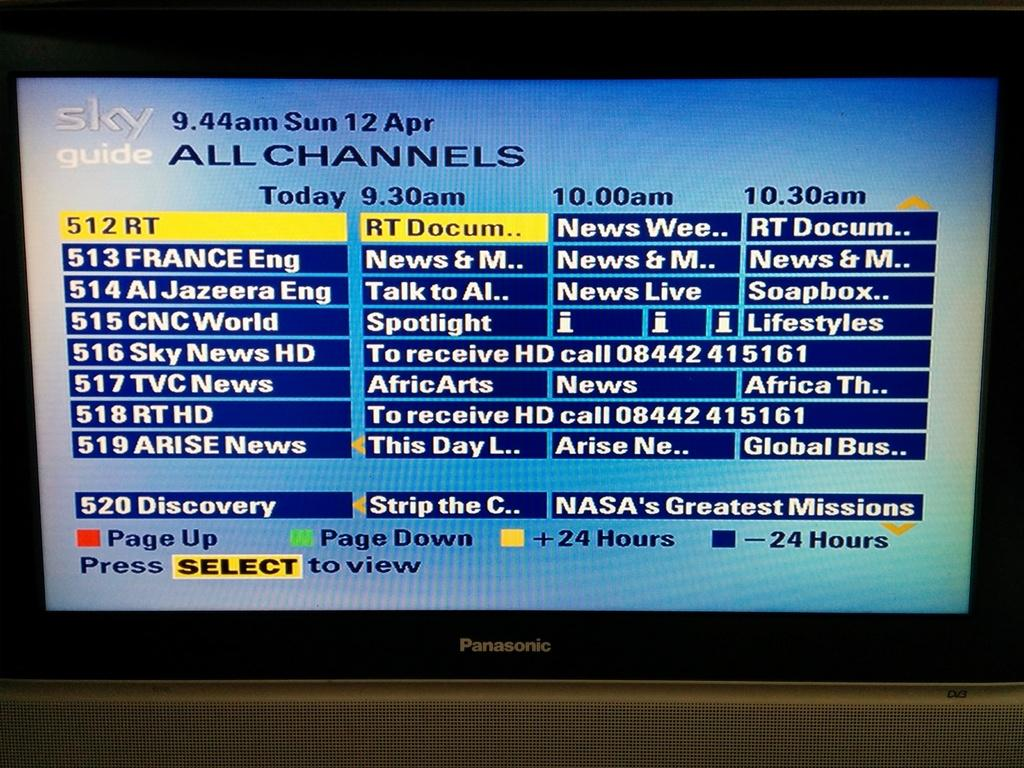Provide a one-sentence caption for the provided image. a panasonice tv with sky tv guide page on it. 